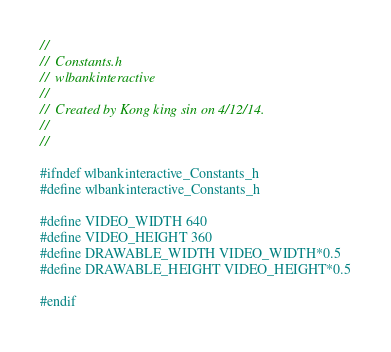<code> <loc_0><loc_0><loc_500><loc_500><_C_>//
//  Constants.h
//  wlbankinteractive
//
//  Created by Kong king sin on 4/12/14.
//
//

#ifndef wlbankinteractive_Constants_h
#define wlbankinteractive_Constants_h

#define VIDEO_WIDTH 640
#define VIDEO_HEIGHT 360    
#define DRAWABLE_WIDTH VIDEO_WIDTH*0.5
#define DRAWABLE_HEIGHT VIDEO_HEIGHT*0.5

#endif
</code> 